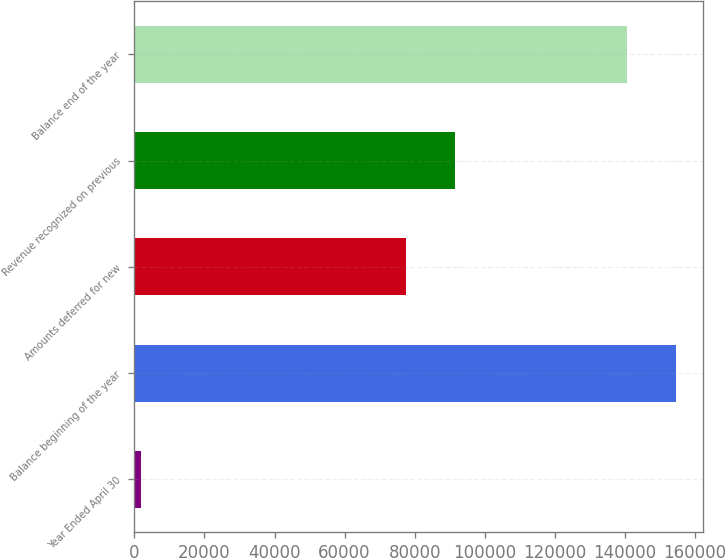Convert chart to OTSL. <chart><loc_0><loc_0><loc_500><loc_500><bar_chart><fcel>Year Ended April 30<fcel>Balance beginning of the year<fcel>Amounts deferred for new<fcel>Revenue recognized on previous<fcel>Balance end of the year<nl><fcel>2011<fcel>154556<fcel>77474<fcel>91427.1<fcel>140603<nl></chart> 